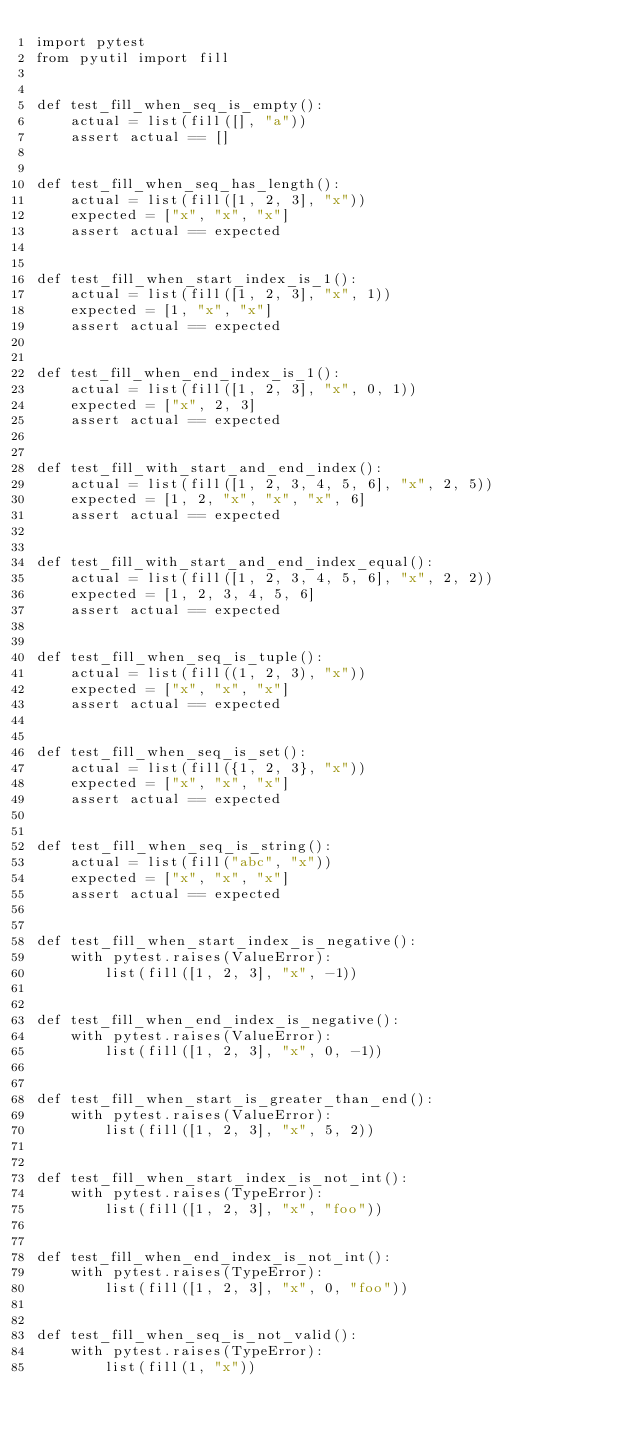<code> <loc_0><loc_0><loc_500><loc_500><_Python_>import pytest
from pyutil import fill


def test_fill_when_seq_is_empty():
    actual = list(fill([], "a"))
    assert actual == []


def test_fill_when_seq_has_length():
    actual = list(fill([1, 2, 3], "x"))
    expected = ["x", "x", "x"]
    assert actual == expected


def test_fill_when_start_index_is_1():
    actual = list(fill([1, 2, 3], "x", 1))
    expected = [1, "x", "x"]
    assert actual == expected


def test_fill_when_end_index_is_1():
    actual = list(fill([1, 2, 3], "x", 0, 1))
    expected = ["x", 2, 3]
    assert actual == expected


def test_fill_with_start_and_end_index():
    actual = list(fill([1, 2, 3, 4, 5, 6], "x", 2, 5))
    expected = [1, 2, "x", "x", "x", 6]
    assert actual == expected


def test_fill_with_start_and_end_index_equal():
    actual = list(fill([1, 2, 3, 4, 5, 6], "x", 2, 2))
    expected = [1, 2, 3, 4, 5, 6]
    assert actual == expected


def test_fill_when_seq_is_tuple():
    actual = list(fill((1, 2, 3), "x"))
    expected = ["x", "x", "x"]
    assert actual == expected


def test_fill_when_seq_is_set():
    actual = list(fill({1, 2, 3}, "x"))
    expected = ["x", "x", "x"]
    assert actual == expected


def test_fill_when_seq_is_string():
    actual = list(fill("abc", "x"))
    expected = ["x", "x", "x"]
    assert actual == expected


def test_fill_when_start_index_is_negative():
    with pytest.raises(ValueError):
        list(fill([1, 2, 3], "x", -1))


def test_fill_when_end_index_is_negative():
    with pytest.raises(ValueError):
        list(fill([1, 2, 3], "x", 0, -1))


def test_fill_when_start_is_greater_than_end():
    with pytest.raises(ValueError):
        list(fill([1, 2, 3], "x", 5, 2))


def test_fill_when_start_index_is_not_int():
    with pytest.raises(TypeError):
        list(fill([1, 2, 3], "x", "foo"))


def test_fill_when_end_index_is_not_int():
    with pytest.raises(TypeError):
        list(fill([1, 2, 3], "x", 0, "foo"))


def test_fill_when_seq_is_not_valid():
    with pytest.raises(TypeError):
        list(fill(1, "x"))
</code> 